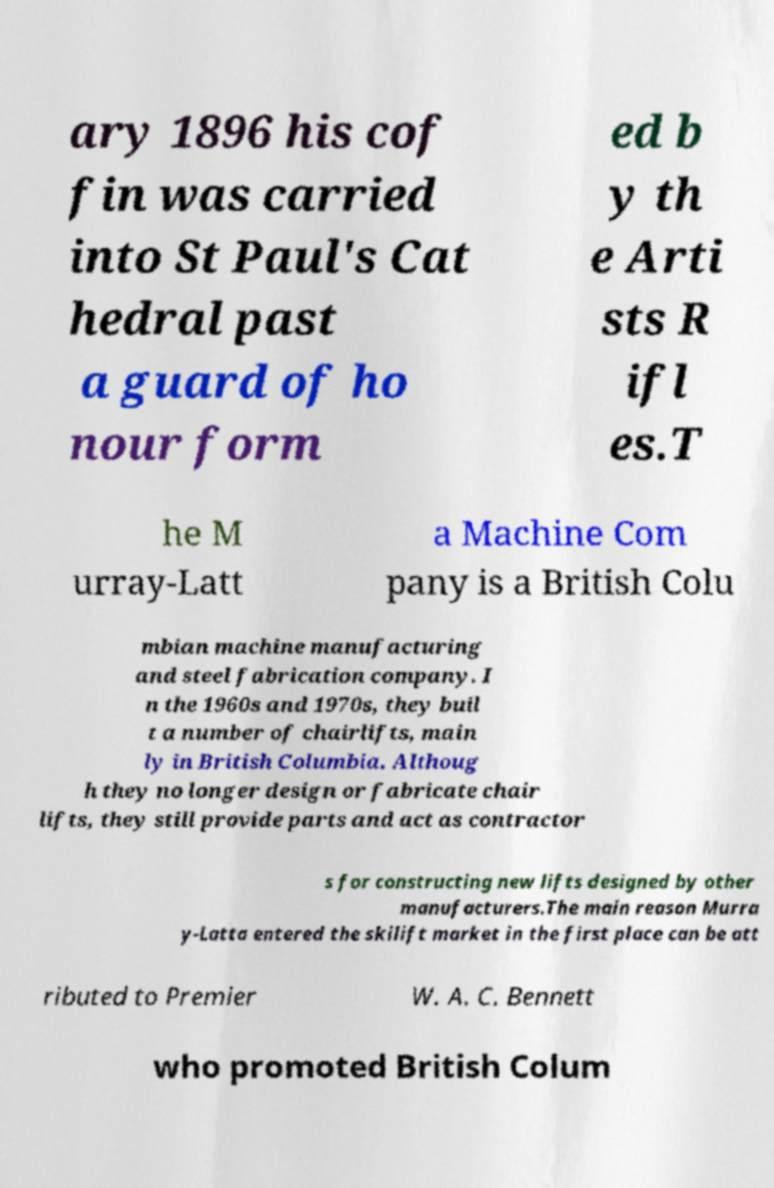What messages or text are displayed in this image? I need them in a readable, typed format. ary 1896 his cof fin was carried into St Paul's Cat hedral past a guard of ho nour form ed b y th e Arti sts R ifl es.T he M urray-Latt a Machine Com pany is a British Colu mbian machine manufacturing and steel fabrication company. I n the 1960s and 1970s, they buil t a number of chairlifts, main ly in British Columbia. Althoug h they no longer design or fabricate chair lifts, they still provide parts and act as contractor s for constructing new lifts designed by other manufacturers.The main reason Murra y-Latta entered the skilift market in the first place can be att ributed to Premier W. A. C. Bennett who promoted British Colum 